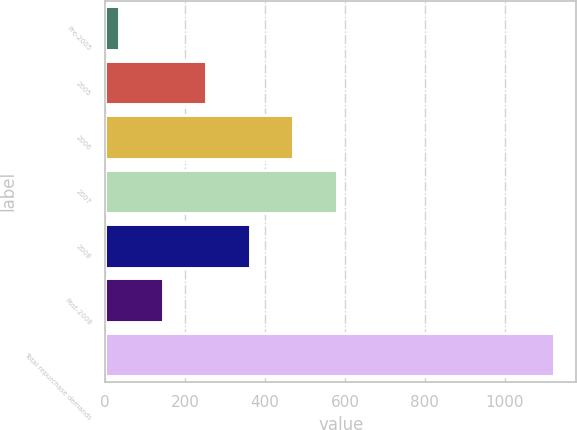<chart> <loc_0><loc_0><loc_500><loc_500><bar_chart><fcel>Pre-2005<fcel>2005<fcel>2006<fcel>2007<fcel>2008<fcel>Post-2008<fcel>Total repurchase demands<nl><fcel>35<fcel>252.6<fcel>470.2<fcel>579<fcel>361.4<fcel>143.8<fcel>1123<nl></chart> 